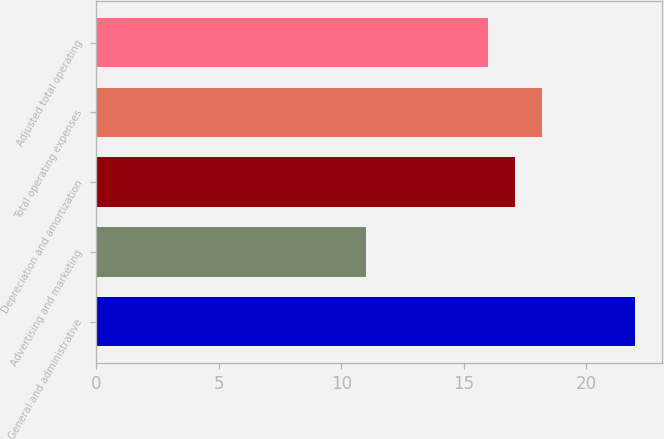Convert chart. <chart><loc_0><loc_0><loc_500><loc_500><bar_chart><fcel>General and administrative<fcel>Advertising and marketing<fcel>Depreciation and amortization<fcel>Total operating expenses<fcel>Adjusted total operating<nl><fcel>22<fcel>11<fcel>17.1<fcel>18.2<fcel>16<nl></chart> 